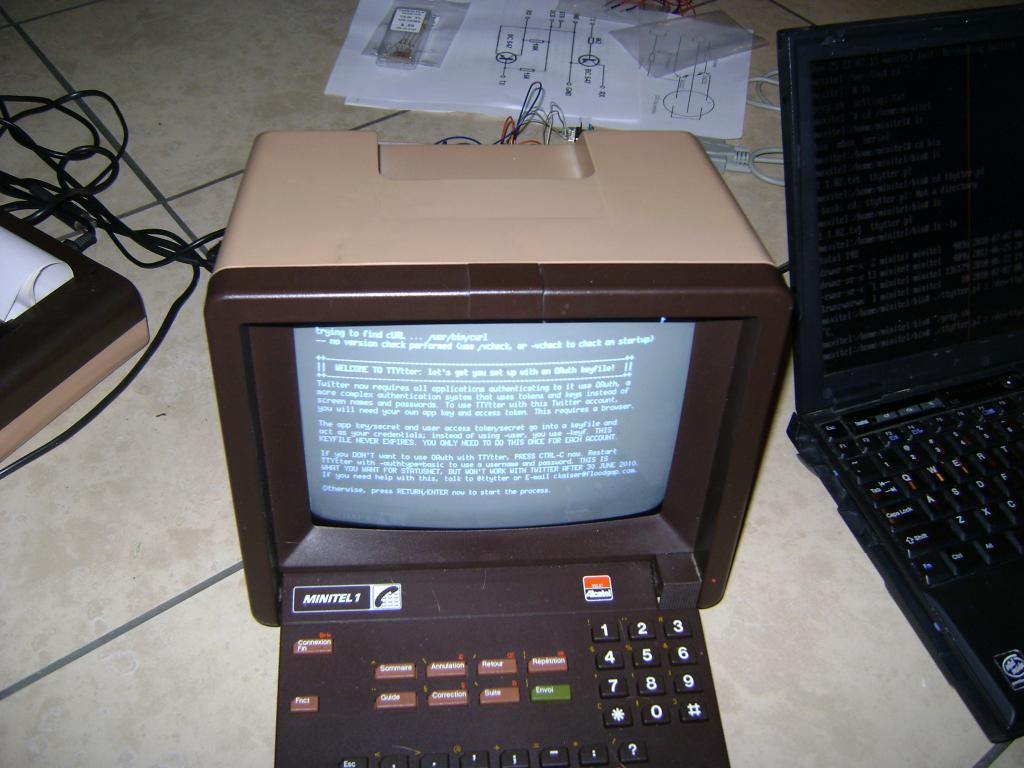What color is the computer in the image? The computer in the image is black. Where is the computer placed? The computer is placed on the flooring tile. What other type of computer can be seen in the image? There is a laptop in the image. What can be seen in the background of the image? White papers and cables are visible in the background. What type of vest is the computer wearing in the image? The computer is not wearing a vest, as it is an inanimate object and does not have the ability to wear clothing. 